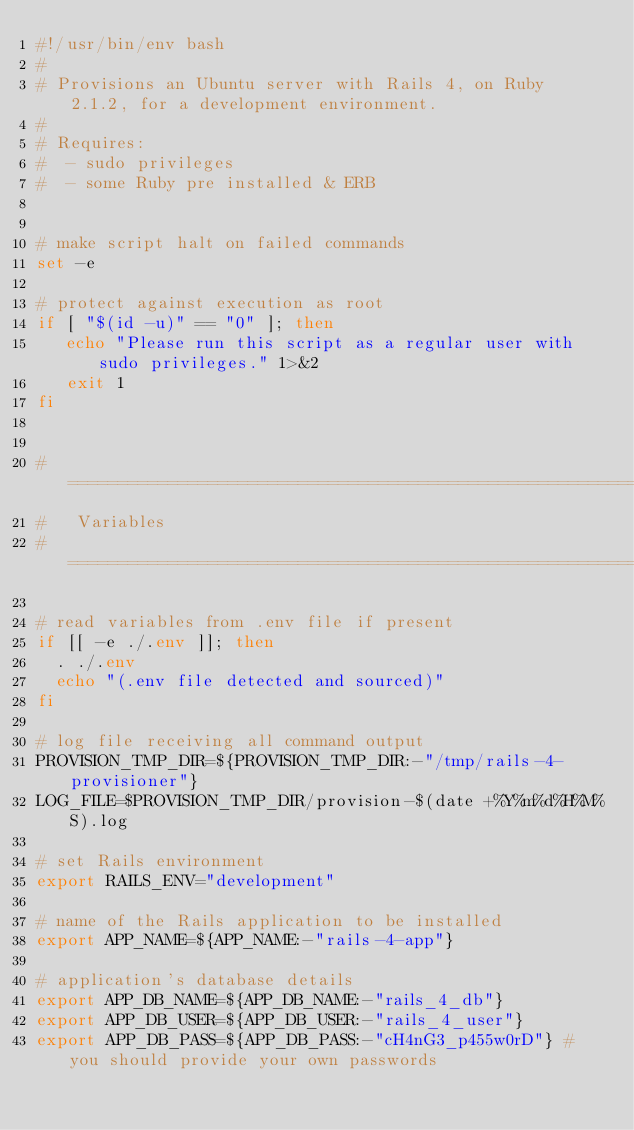<code> <loc_0><loc_0><loc_500><loc_500><_Bash_>#!/usr/bin/env bash
#
# Provisions an Ubuntu server with Rails 4, on Ruby 2.1.2, for a development environment.
#
# Requires:
#  - sudo privileges
#  - some Ruby pre installed & ERB 


# make script halt on failed commands
set -e

# protect against execution as root
if [ "$(id -u)" == "0" ]; then
   echo "Please run this script as a regular user with sudo privileges." 1>&2
   exit 1
fi


# =============================================================================
#   Variables
# =============================================================================

# read variables from .env file if present
if [[ -e ./.env ]]; then
  . ./.env
  echo "(.env file detected and sourced)"
fi

# log file receiving all command output
PROVISION_TMP_DIR=${PROVISION_TMP_DIR:-"/tmp/rails-4-provisioner"}
LOG_FILE=$PROVISION_TMP_DIR/provision-$(date +%Y%m%d%H%M%S).log

# set Rails environment
export RAILS_ENV="development"

# name of the Rails application to be installed
export APP_NAME=${APP_NAME:-"rails-4-app"}

# application's database details
export APP_DB_NAME=${APP_DB_NAME:-"rails_4_db"}
export APP_DB_USER=${APP_DB_USER:-"rails_4_user"}
export APP_DB_PASS=${APP_DB_PASS:-"cH4nG3_p455w0rD"} # you should provide your own passwords
</code> 